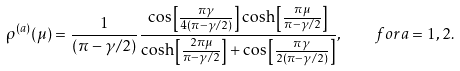<formula> <loc_0><loc_0><loc_500><loc_500>\rho ^ { ( a ) } ( \mu ) = \frac { 1 } { ( \pi - { \gamma } / 2 ) } \frac { \cos \left [ \frac { \pi { \gamma } } { 4 ( \pi - { \gamma } / 2 ) } \right ] \cosh \left [ \frac { \pi \mu } { \pi - { \gamma } / 2 } \right ] } { \cosh \left [ \frac { 2 \pi \mu } { \pi - { \gamma } / 2 } \right ] + \cos \left [ \frac { \pi { \gamma } } { 2 ( \pi - { \gamma } / 2 ) } \right ] } , \quad f o r a = 1 , 2 .</formula> 